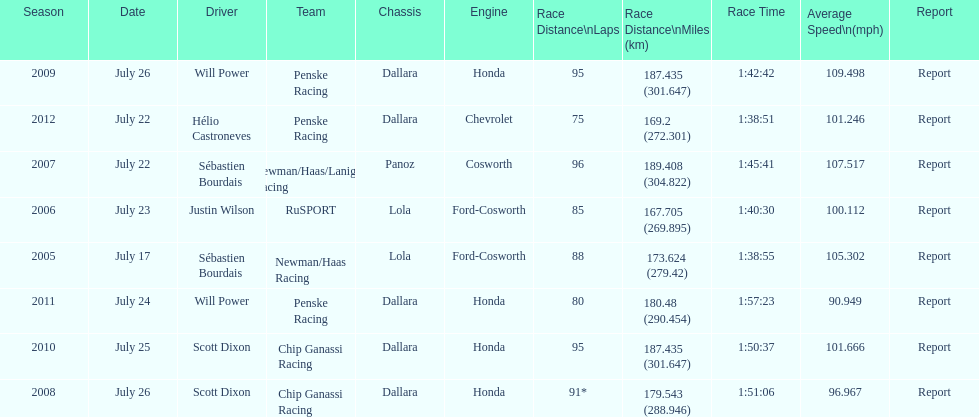How many total honda engines were there? 4. 